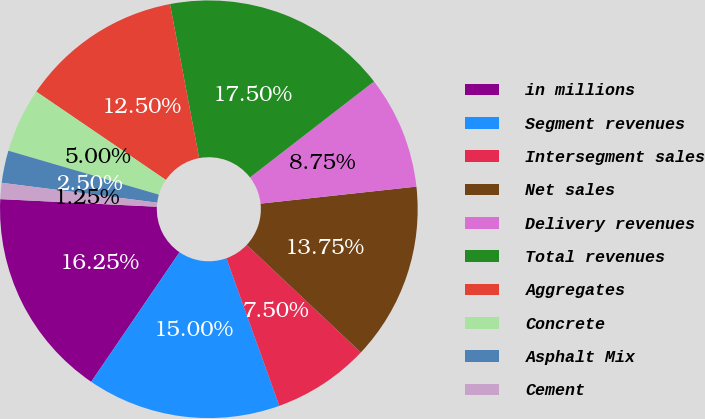<chart> <loc_0><loc_0><loc_500><loc_500><pie_chart><fcel>in millions<fcel>Segment revenues<fcel>Intersegment sales<fcel>Net sales<fcel>Delivery revenues<fcel>Total revenues<fcel>Aggregates<fcel>Concrete<fcel>Asphalt Mix<fcel>Cement<nl><fcel>16.25%<fcel>15.0%<fcel>7.5%<fcel>13.75%<fcel>8.75%<fcel>17.5%<fcel>12.5%<fcel>5.0%<fcel>2.5%<fcel>1.25%<nl></chart> 